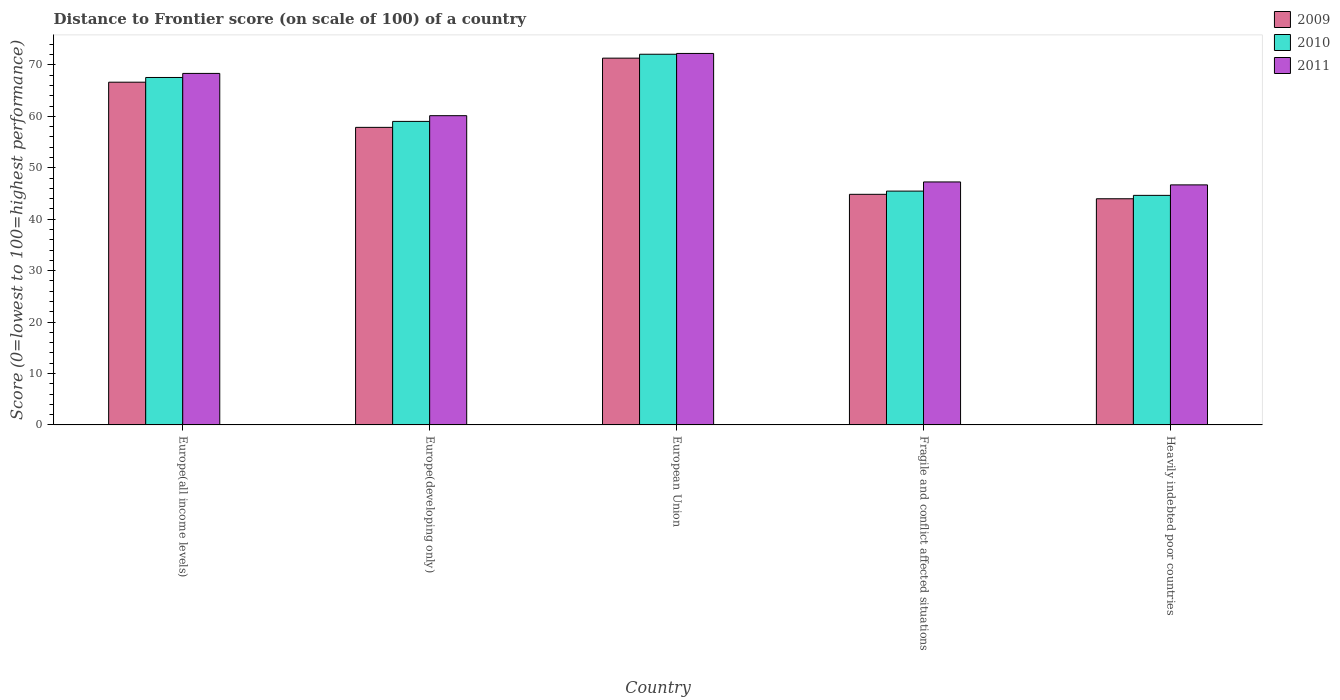Are the number of bars per tick equal to the number of legend labels?
Offer a very short reply. Yes. Are the number of bars on each tick of the X-axis equal?
Provide a succinct answer. Yes. What is the label of the 5th group of bars from the left?
Your answer should be very brief. Heavily indebted poor countries. In how many cases, is the number of bars for a given country not equal to the number of legend labels?
Make the answer very short. 0. What is the distance to frontier score of in 2011 in Fragile and conflict affected situations?
Make the answer very short. 47.25. Across all countries, what is the maximum distance to frontier score of in 2009?
Keep it short and to the point. 71.32. Across all countries, what is the minimum distance to frontier score of in 2009?
Offer a very short reply. 43.98. In which country was the distance to frontier score of in 2010 minimum?
Keep it short and to the point. Heavily indebted poor countries. What is the total distance to frontier score of in 2009 in the graph?
Provide a short and direct response. 284.63. What is the difference between the distance to frontier score of in 2009 in European Union and that in Heavily indebted poor countries?
Your response must be concise. 27.34. What is the difference between the distance to frontier score of in 2010 in Fragile and conflict affected situations and the distance to frontier score of in 2011 in Europe(developing only)?
Provide a short and direct response. -14.67. What is the average distance to frontier score of in 2010 per country?
Your response must be concise. 57.75. What is the difference between the distance to frontier score of of/in 2009 and distance to frontier score of of/in 2010 in Europe(all income levels)?
Make the answer very short. -0.92. In how many countries, is the distance to frontier score of in 2009 greater than 46?
Provide a short and direct response. 3. What is the ratio of the distance to frontier score of in 2009 in Europe(all income levels) to that in Heavily indebted poor countries?
Offer a terse response. 1.52. Is the distance to frontier score of in 2009 in Europe(developing only) less than that in Heavily indebted poor countries?
Your answer should be very brief. No. What is the difference between the highest and the second highest distance to frontier score of in 2009?
Offer a very short reply. -8.78. What is the difference between the highest and the lowest distance to frontier score of in 2009?
Your response must be concise. 27.34. In how many countries, is the distance to frontier score of in 2011 greater than the average distance to frontier score of in 2011 taken over all countries?
Your answer should be compact. 3. What does the 1st bar from the left in Fragile and conflict affected situations represents?
Offer a terse response. 2009. What does the 2nd bar from the right in Fragile and conflict affected situations represents?
Your answer should be very brief. 2010. Is it the case that in every country, the sum of the distance to frontier score of in 2009 and distance to frontier score of in 2010 is greater than the distance to frontier score of in 2011?
Offer a very short reply. Yes. How many bars are there?
Your answer should be very brief. 15. How many legend labels are there?
Your response must be concise. 3. What is the title of the graph?
Ensure brevity in your answer.  Distance to Frontier score (on scale of 100) of a country. What is the label or title of the X-axis?
Your response must be concise. Country. What is the label or title of the Y-axis?
Keep it short and to the point. Score (0=lowest to 100=highest performance). What is the Score (0=lowest to 100=highest performance) of 2009 in Europe(all income levels)?
Your answer should be very brief. 66.64. What is the Score (0=lowest to 100=highest performance) of 2010 in Europe(all income levels)?
Offer a very short reply. 67.56. What is the Score (0=lowest to 100=highest performance) of 2011 in Europe(all income levels)?
Your answer should be very brief. 68.35. What is the Score (0=lowest to 100=highest performance) of 2009 in Europe(developing only)?
Give a very brief answer. 57.86. What is the Score (0=lowest to 100=highest performance) in 2010 in Europe(developing only)?
Your answer should be compact. 59.02. What is the Score (0=lowest to 100=highest performance) in 2011 in Europe(developing only)?
Offer a terse response. 60.13. What is the Score (0=lowest to 100=highest performance) of 2009 in European Union?
Offer a very short reply. 71.32. What is the Score (0=lowest to 100=highest performance) of 2010 in European Union?
Your answer should be very brief. 72.08. What is the Score (0=lowest to 100=highest performance) of 2011 in European Union?
Provide a short and direct response. 72.23. What is the Score (0=lowest to 100=highest performance) in 2009 in Fragile and conflict affected situations?
Ensure brevity in your answer.  44.84. What is the Score (0=lowest to 100=highest performance) in 2010 in Fragile and conflict affected situations?
Make the answer very short. 45.46. What is the Score (0=lowest to 100=highest performance) of 2011 in Fragile and conflict affected situations?
Your response must be concise. 47.25. What is the Score (0=lowest to 100=highest performance) in 2009 in Heavily indebted poor countries?
Offer a very short reply. 43.98. What is the Score (0=lowest to 100=highest performance) of 2010 in Heavily indebted poor countries?
Keep it short and to the point. 44.64. What is the Score (0=lowest to 100=highest performance) of 2011 in Heavily indebted poor countries?
Your answer should be compact. 46.67. Across all countries, what is the maximum Score (0=lowest to 100=highest performance) of 2009?
Your answer should be compact. 71.32. Across all countries, what is the maximum Score (0=lowest to 100=highest performance) of 2010?
Make the answer very short. 72.08. Across all countries, what is the maximum Score (0=lowest to 100=highest performance) in 2011?
Offer a very short reply. 72.23. Across all countries, what is the minimum Score (0=lowest to 100=highest performance) in 2009?
Make the answer very short. 43.98. Across all countries, what is the minimum Score (0=lowest to 100=highest performance) in 2010?
Keep it short and to the point. 44.64. Across all countries, what is the minimum Score (0=lowest to 100=highest performance) of 2011?
Ensure brevity in your answer.  46.67. What is the total Score (0=lowest to 100=highest performance) of 2009 in the graph?
Your answer should be compact. 284.63. What is the total Score (0=lowest to 100=highest performance) in 2010 in the graph?
Your answer should be compact. 288.75. What is the total Score (0=lowest to 100=highest performance) in 2011 in the graph?
Provide a succinct answer. 294.63. What is the difference between the Score (0=lowest to 100=highest performance) in 2009 in Europe(all income levels) and that in Europe(developing only)?
Your answer should be very brief. 8.78. What is the difference between the Score (0=lowest to 100=highest performance) in 2010 in Europe(all income levels) and that in Europe(developing only)?
Keep it short and to the point. 8.54. What is the difference between the Score (0=lowest to 100=highest performance) of 2011 in Europe(all income levels) and that in Europe(developing only)?
Ensure brevity in your answer.  8.22. What is the difference between the Score (0=lowest to 100=highest performance) of 2009 in Europe(all income levels) and that in European Union?
Your answer should be compact. -4.68. What is the difference between the Score (0=lowest to 100=highest performance) in 2010 in Europe(all income levels) and that in European Union?
Keep it short and to the point. -4.52. What is the difference between the Score (0=lowest to 100=highest performance) of 2011 in Europe(all income levels) and that in European Union?
Provide a succinct answer. -3.88. What is the difference between the Score (0=lowest to 100=highest performance) in 2009 in Europe(all income levels) and that in Fragile and conflict affected situations?
Make the answer very short. 21.8. What is the difference between the Score (0=lowest to 100=highest performance) of 2010 in Europe(all income levels) and that in Fragile and conflict affected situations?
Keep it short and to the point. 22.1. What is the difference between the Score (0=lowest to 100=highest performance) in 2011 in Europe(all income levels) and that in Fragile and conflict affected situations?
Keep it short and to the point. 21.1. What is the difference between the Score (0=lowest to 100=highest performance) in 2009 in Europe(all income levels) and that in Heavily indebted poor countries?
Offer a terse response. 22.67. What is the difference between the Score (0=lowest to 100=highest performance) in 2010 in Europe(all income levels) and that in Heavily indebted poor countries?
Offer a very short reply. 22.92. What is the difference between the Score (0=lowest to 100=highest performance) of 2011 in Europe(all income levels) and that in Heavily indebted poor countries?
Ensure brevity in your answer.  21.68. What is the difference between the Score (0=lowest to 100=highest performance) in 2009 in Europe(developing only) and that in European Union?
Provide a short and direct response. -13.46. What is the difference between the Score (0=lowest to 100=highest performance) of 2010 in Europe(developing only) and that in European Union?
Offer a very short reply. -13.06. What is the difference between the Score (0=lowest to 100=highest performance) in 2011 in Europe(developing only) and that in European Union?
Offer a terse response. -12.1. What is the difference between the Score (0=lowest to 100=highest performance) in 2009 in Europe(developing only) and that in Fragile and conflict affected situations?
Offer a very short reply. 13.02. What is the difference between the Score (0=lowest to 100=highest performance) in 2010 in Europe(developing only) and that in Fragile and conflict affected situations?
Keep it short and to the point. 13.55. What is the difference between the Score (0=lowest to 100=highest performance) of 2011 in Europe(developing only) and that in Fragile and conflict affected situations?
Make the answer very short. 12.88. What is the difference between the Score (0=lowest to 100=highest performance) in 2009 in Europe(developing only) and that in Heavily indebted poor countries?
Make the answer very short. 13.88. What is the difference between the Score (0=lowest to 100=highest performance) in 2010 in Europe(developing only) and that in Heavily indebted poor countries?
Offer a very short reply. 14.38. What is the difference between the Score (0=lowest to 100=highest performance) in 2011 in Europe(developing only) and that in Heavily indebted poor countries?
Provide a short and direct response. 13.46. What is the difference between the Score (0=lowest to 100=highest performance) in 2009 in European Union and that in Fragile and conflict affected situations?
Offer a terse response. 26.48. What is the difference between the Score (0=lowest to 100=highest performance) in 2010 in European Union and that in Fragile and conflict affected situations?
Give a very brief answer. 26.61. What is the difference between the Score (0=lowest to 100=highest performance) of 2011 in European Union and that in Fragile and conflict affected situations?
Provide a short and direct response. 24.99. What is the difference between the Score (0=lowest to 100=highest performance) in 2009 in European Union and that in Heavily indebted poor countries?
Ensure brevity in your answer.  27.34. What is the difference between the Score (0=lowest to 100=highest performance) of 2010 in European Union and that in Heavily indebted poor countries?
Your answer should be very brief. 27.44. What is the difference between the Score (0=lowest to 100=highest performance) of 2011 in European Union and that in Heavily indebted poor countries?
Give a very brief answer. 25.56. What is the difference between the Score (0=lowest to 100=highest performance) in 2009 in Fragile and conflict affected situations and that in Heavily indebted poor countries?
Provide a succinct answer. 0.86. What is the difference between the Score (0=lowest to 100=highest performance) of 2010 in Fragile and conflict affected situations and that in Heavily indebted poor countries?
Provide a short and direct response. 0.83. What is the difference between the Score (0=lowest to 100=highest performance) of 2011 in Fragile and conflict affected situations and that in Heavily indebted poor countries?
Keep it short and to the point. 0.57. What is the difference between the Score (0=lowest to 100=highest performance) in 2009 in Europe(all income levels) and the Score (0=lowest to 100=highest performance) in 2010 in Europe(developing only)?
Provide a succinct answer. 7.62. What is the difference between the Score (0=lowest to 100=highest performance) of 2009 in Europe(all income levels) and the Score (0=lowest to 100=highest performance) of 2011 in Europe(developing only)?
Provide a short and direct response. 6.51. What is the difference between the Score (0=lowest to 100=highest performance) in 2010 in Europe(all income levels) and the Score (0=lowest to 100=highest performance) in 2011 in Europe(developing only)?
Offer a very short reply. 7.43. What is the difference between the Score (0=lowest to 100=highest performance) in 2009 in Europe(all income levels) and the Score (0=lowest to 100=highest performance) in 2010 in European Union?
Provide a succinct answer. -5.43. What is the difference between the Score (0=lowest to 100=highest performance) of 2009 in Europe(all income levels) and the Score (0=lowest to 100=highest performance) of 2011 in European Union?
Provide a short and direct response. -5.59. What is the difference between the Score (0=lowest to 100=highest performance) of 2010 in Europe(all income levels) and the Score (0=lowest to 100=highest performance) of 2011 in European Union?
Keep it short and to the point. -4.67. What is the difference between the Score (0=lowest to 100=highest performance) in 2009 in Europe(all income levels) and the Score (0=lowest to 100=highest performance) in 2010 in Fragile and conflict affected situations?
Offer a very short reply. 21.18. What is the difference between the Score (0=lowest to 100=highest performance) of 2009 in Europe(all income levels) and the Score (0=lowest to 100=highest performance) of 2011 in Fragile and conflict affected situations?
Your response must be concise. 19.4. What is the difference between the Score (0=lowest to 100=highest performance) of 2010 in Europe(all income levels) and the Score (0=lowest to 100=highest performance) of 2011 in Fragile and conflict affected situations?
Your answer should be compact. 20.31. What is the difference between the Score (0=lowest to 100=highest performance) of 2009 in Europe(all income levels) and the Score (0=lowest to 100=highest performance) of 2010 in Heavily indebted poor countries?
Your response must be concise. 22.01. What is the difference between the Score (0=lowest to 100=highest performance) of 2009 in Europe(all income levels) and the Score (0=lowest to 100=highest performance) of 2011 in Heavily indebted poor countries?
Offer a terse response. 19.97. What is the difference between the Score (0=lowest to 100=highest performance) in 2010 in Europe(all income levels) and the Score (0=lowest to 100=highest performance) in 2011 in Heavily indebted poor countries?
Ensure brevity in your answer.  20.89. What is the difference between the Score (0=lowest to 100=highest performance) in 2009 in Europe(developing only) and the Score (0=lowest to 100=highest performance) in 2010 in European Union?
Your response must be concise. -14.22. What is the difference between the Score (0=lowest to 100=highest performance) in 2009 in Europe(developing only) and the Score (0=lowest to 100=highest performance) in 2011 in European Union?
Keep it short and to the point. -14.37. What is the difference between the Score (0=lowest to 100=highest performance) of 2010 in Europe(developing only) and the Score (0=lowest to 100=highest performance) of 2011 in European Union?
Keep it short and to the point. -13.21. What is the difference between the Score (0=lowest to 100=highest performance) of 2009 in Europe(developing only) and the Score (0=lowest to 100=highest performance) of 2010 in Fragile and conflict affected situations?
Your answer should be compact. 12.39. What is the difference between the Score (0=lowest to 100=highest performance) of 2009 in Europe(developing only) and the Score (0=lowest to 100=highest performance) of 2011 in Fragile and conflict affected situations?
Offer a terse response. 10.61. What is the difference between the Score (0=lowest to 100=highest performance) in 2010 in Europe(developing only) and the Score (0=lowest to 100=highest performance) in 2011 in Fragile and conflict affected situations?
Give a very brief answer. 11.77. What is the difference between the Score (0=lowest to 100=highest performance) in 2009 in Europe(developing only) and the Score (0=lowest to 100=highest performance) in 2010 in Heavily indebted poor countries?
Keep it short and to the point. 13.22. What is the difference between the Score (0=lowest to 100=highest performance) of 2009 in Europe(developing only) and the Score (0=lowest to 100=highest performance) of 2011 in Heavily indebted poor countries?
Give a very brief answer. 11.18. What is the difference between the Score (0=lowest to 100=highest performance) of 2010 in Europe(developing only) and the Score (0=lowest to 100=highest performance) of 2011 in Heavily indebted poor countries?
Ensure brevity in your answer.  12.35. What is the difference between the Score (0=lowest to 100=highest performance) of 2009 in European Union and the Score (0=lowest to 100=highest performance) of 2010 in Fragile and conflict affected situations?
Offer a very short reply. 25.85. What is the difference between the Score (0=lowest to 100=highest performance) in 2009 in European Union and the Score (0=lowest to 100=highest performance) in 2011 in Fragile and conflict affected situations?
Provide a short and direct response. 24.07. What is the difference between the Score (0=lowest to 100=highest performance) of 2010 in European Union and the Score (0=lowest to 100=highest performance) of 2011 in Fragile and conflict affected situations?
Offer a terse response. 24.83. What is the difference between the Score (0=lowest to 100=highest performance) in 2009 in European Union and the Score (0=lowest to 100=highest performance) in 2010 in Heavily indebted poor countries?
Your answer should be very brief. 26.68. What is the difference between the Score (0=lowest to 100=highest performance) of 2009 in European Union and the Score (0=lowest to 100=highest performance) of 2011 in Heavily indebted poor countries?
Your answer should be compact. 24.65. What is the difference between the Score (0=lowest to 100=highest performance) in 2010 in European Union and the Score (0=lowest to 100=highest performance) in 2011 in Heavily indebted poor countries?
Keep it short and to the point. 25.4. What is the difference between the Score (0=lowest to 100=highest performance) of 2009 in Fragile and conflict affected situations and the Score (0=lowest to 100=highest performance) of 2010 in Heavily indebted poor countries?
Offer a terse response. 0.2. What is the difference between the Score (0=lowest to 100=highest performance) in 2009 in Fragile and conflict affected situations and the Score (0=lowest to 100=highest performance) in 2011 in Heavily indebted poor countries?
Provide a succinct answer. -1.83. What is the difference between the Score (0=lowest to 100=highest performance) in 2010 in Fragile and conflict affected situations and the Score (0=lowest to 100=highest performance) in 2011 in Heavily indebted poor countries?
Offer a very short reply. -1.21. What is the average Score (0=lowest to 100=highest performance) in 2009 per country?
Your answer should be compact. 56.93. What is the average Score (0=lowest to 100=highest performance) of 2010 per country?
Make the answer very short. 57.75. What is the average Score (0=lowest to 100=highest performance) of 2011 per country?
Ensure brevity in your answer.  58.93. What is the difference between the Score (0=lowest to 100=highest performance) in 2009 and Score (0=lowest to 100=highest performance) in 2010 in Europe(all income levels)?
Keep it short and to the point. -0.92. What is the difference between the Score (0=lowest to 100=highest performance) in 2009 and Score (0=lowest to 100=highest performance) in 2011 in Europe(all income levels)?
Keep it short and to the point. -1.71. What is the difference between the Score (0=lowest to 100=highest performance) in 2010 and Score (0=lowest to 100=highest performance) in 2011 in Europe(all income levels)?
Your answer should be very brief. -0.79. What is the difference between the Score (0=lowest to 100=highest performance) of 2009 and Score (0=lowest to 100=highest performance) of 2010 in Europe(developing only)?
Provide a short and direct response. -1.16. What is the difference between the Score (0=lowest to 100=highest performance) in 2009 and Score (0=lowest to 100=highest performance) in 2011 in Europe(developing only)?
Provide a succinct answer. -2.27. What is the difference between the Score (0=lowest to 100=highest performance) in 2010 and Score (0=lowest to 100=highest performance) in 2011 in Europe(developing only)?
Provide a succinct answer. -1.11. What is the difference between the Score (0=lowest to 100=highest performance) of 2009 and Score (0=lowest to 100=highest performance) of 2010 in European Union?
Provide a succinct answer. -0.76. What is the difference between the Score (0=lowest to 100=highest performance) of 2009 and Score (0=lowest to 100=highest performance) of 2011 in European Union?
Provide a short and direct response. -0.91. What is the difference between the Score (0=lowest to 100=highest performance) of 2010 and Score (0=lowest to 100=highest performance) of 2011 in European Union?
Offer a terse response. -0.15. What is the difference between the Score (0=lowest to 100=highest performance) of 2009 and Score (0=lowest to 100=highest performance) of 2010 in Fragile and conflict affected situations?
Offer a very short reply. -0.63. What is the difference between the Score (0=lowest to 100=highest performance) in 2009 and Score (0=lowest to 100=highest performance) in 2011 in Fragile and conflict affected situations?
Give a very brief answer. -2.41. What is the difference between the Score (0=lowest to 100=highest performance) in 2010 and Score (0=lowest to 100=highest performance) in 2011 in Fragile and conflict affected situations?
Provide a short and direct response. -1.78. What is the difference between the Score (0=lowest to 100=highest performance) of 2009 and Score (0=lowest to 100=highest performance) of 2010 in Heavily indebted poor countries?
Keep it short and to the point. -0.66. What is the difference between the Score (0=lowest to 100=highest performance) of 2009 and Score (0=lowest to 100=highest performance) of 2011 in Heavily indebted poor countries?
Provide a succinct answer. -2.7. What is the difference between the Score (0=lowest to 100=highest performance) of 2010 and Score (0=lowest to 100=highest performance) of 2011 in Heavily indebted poor countries?
Provide a short and direct response. -2.04. What is the ratio of the Score (0=lowest to 100=highest performance) of 2009 in Europe(all income levels) to that in Europe(developing only)?
Your answer should be very brief. 1.15. What is the ratio of the Score (0=lowest to 100=highest performance) in 2010 in Europe(all income levels) to that in Europe(developing only)?
Make the answer very short. 1.14. What is the ratio of the Score (0=lowest to 100=highest performance) of 2011 in Europe(all income levels) to that in Europe(developing only)?
Keep it short and to the point. 1.14. What is the ratio of the Score (0=lowest to 100=highest performance) in 2009 in Europe(all income levels) to that in European Union?
Offer a terse response. 0.93. What is the ratio of the Score (0=lowest to 100=highest performance) of 2010 in Europe(all income levels) to that in European Union?
Your answer should be very brief. 0.94. What is the ratio of the Score (0=lowest to 100=highest performance) in 2011 in Europe(all income levels) to that in European Union?
Offer a very short reply. 0.95. What is the ratio of the Score (0=lowest to 100=highest performance) of 2009 in Europe(all income levels) to that in Fragile and conflict affected situations?
Your response must be concise. 1.49. What is the ratio of the Score (0=lowest to 100=highest performance) in 2010 in Europe(all income levels) to that in Fragile and conflict affected situations?
Offer a very short reply. 1.49. What is the ratio of the Score (0=lowest to 100=highest performance) of 2011 in Europe(all income levels) to that in Fragile and conflict affected situations?
Give a very brief answer. 1.45. What is the ratio of the Score (0=lowest to 100=highest performance) of 2009 in Europe(all income levels) to that in Heavily indebted poor countries?
Make the answer very short. 1.52. What is the ratio of the Score (0=lowest to 100=highest performance) of 2010 in Europe(all income levels) to that in Heavily indebted poor countries?
Provide a short and direct response. 1.51. What is the ratio of the Score (0=lowest to 100=highest performance) in 2011 in Europe(all income levels) to that in Heavily indebted poor countries?
Offer a terse response. 1.46. What is the ratio of the Score (0=lowest to 100=highest performance) in 2009 in Europe(developing only) to that in European Union?
Keep it short and to the point. 0.81. What is the ratio of the Score (0=lowest to 100=highest performance) of 2010 in Europe(developing only) to that in European Union?
Make the answer very short. 0.82. What is the ratio of the Score (0=lowest to 100=highest performance) of 2011 in Europe(developing only) to that in European Union?
Make the answer very short. 0.83. What is the ratio of the Score (0=lowest to 100=highest performance) in 2009 in Europe(developing only) to that in Fragile and conflict affected situations?
Your answer should be compact. 1.29. What is the ratio of the Score (0=lowest to 100=highest performance) in 2010 in Europe(developing only) to that in Fragile and conflict affected situations?
Your answer should be compact. 1.3. What is the ratio of the Score (0=lowest to 100=highest performance) in 2011 in Europe(developing only) to that in Fragile and conflict affected situations?
Offer a very short reply. 1.27. What is the ratio of the Score (0=lowest to 100=highest performance) of 2009 in Europe(developing only) to that in Heavily indebted poor countries?
Provide a short and direct response. 1.32. What is the ratio of the Score (0=lowest to 100=highest performance) of 2010 in Europe(developing only) to that in Heavily indebted poor countries?
Offer a terse response. 1.32. What is the ratio of the Score (0=lowest to 100=highest performance) in 2011 in Europe(developing only) to that in Heavily indebted poor countries?
Provide a succinct answer. 1.29. What is the ratio of the Score (0=lowest to 100=highest performance) in 2009 in European Union to that in Fragile and conflict affected situations?
Keep it short and to the point. 1.59. What is the ratio of the Score (0=lowest to 100=highest performance) in 2010 in European Union to that in Fragile and conflict affected situations?
Keep it short and to the point. 1.59. What is the ratio of the Score (0=lowest to 100=highest performance) in 2011 in European Union to that in Fragile and conflict affected situations?
Offer a very short reply. 1.53. What is the ratio of the Score (0=lowest to 100=highest performance) in 2009 in European Union to that in Heavily indebted poor countries?
Keep it short and to the point. 1.62. What is the ratio of the Score (0=lowest to 100=highest performance) of 2010 in European Union to that in Heavily indebted poor countries?
Your answer should be very brief. 1.61. What is the ratio of the Score (0=lowest to 100=highest performance) of 2011 in European Union to that in Heavily indebted poor countries?
Your answer should be very brief. 1.55. What is the ratio of the Score (0=lowest to 100=highest performance) of 2009 in Fragile and conflict affected situations to that in Heavily indebted poor countries?
Offer a very short reply. 1.02. What is the ratio of the Score (0=lowest to 100=highest performance) in 2010 in Fragile and conflict affected situations to that in Heavily indebted poor countries?
Provide a succinct answer. 1.02. What is the ratio of the Score (0=lowest to 100=highest performance) of 2011 in Fragile and conflict affected situations to that in Heavily indebted poor countries?
Offer a terse response. 1.01. What is the difference between the highest and the second highest Score (0=lowest to 100=highest performance) of 2009?
Give a very brief answer. 4.68. What is the difference between the highest and the second highest Score (0=lowest to 100=highest performance) in 2010?
Provide a short and direct response. 4.52. What is the difference between the highest and the second highest Score (0=lowest to 100=highest performance) in 2011?
Your response must be concise. 3.88. What is the difference between the highest and the lowest Score (0=lowest to 100=highest performance) of 2009?
Provide a short and direct response. 27.34. What is the difference between the highest and the lowest Score (0=lowest to 100=highest performance) of 2010?
Make the answer very short. 27.44. What is the difference between the highest and the lowest Score (0=lowest to 100=highest performance) of 2011?
Give a very brief answer. 25.56. 